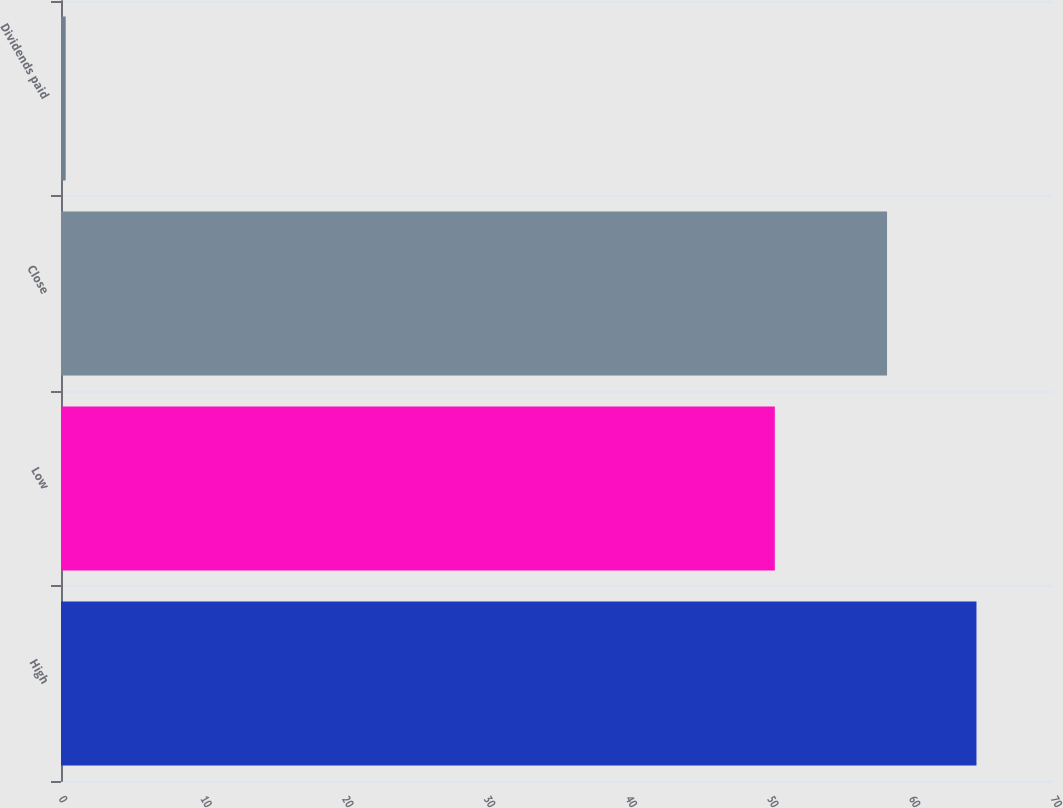<chart> <loc_0><loc_0><loc_500><loc_500><bar_chart><fcel>High<fcel>Low<fcel>Close<fcel>Dividends paid<nl><fcel>64.6<fcel>50.37<fcel>58.29<fcel>0.33<nl></chart> 